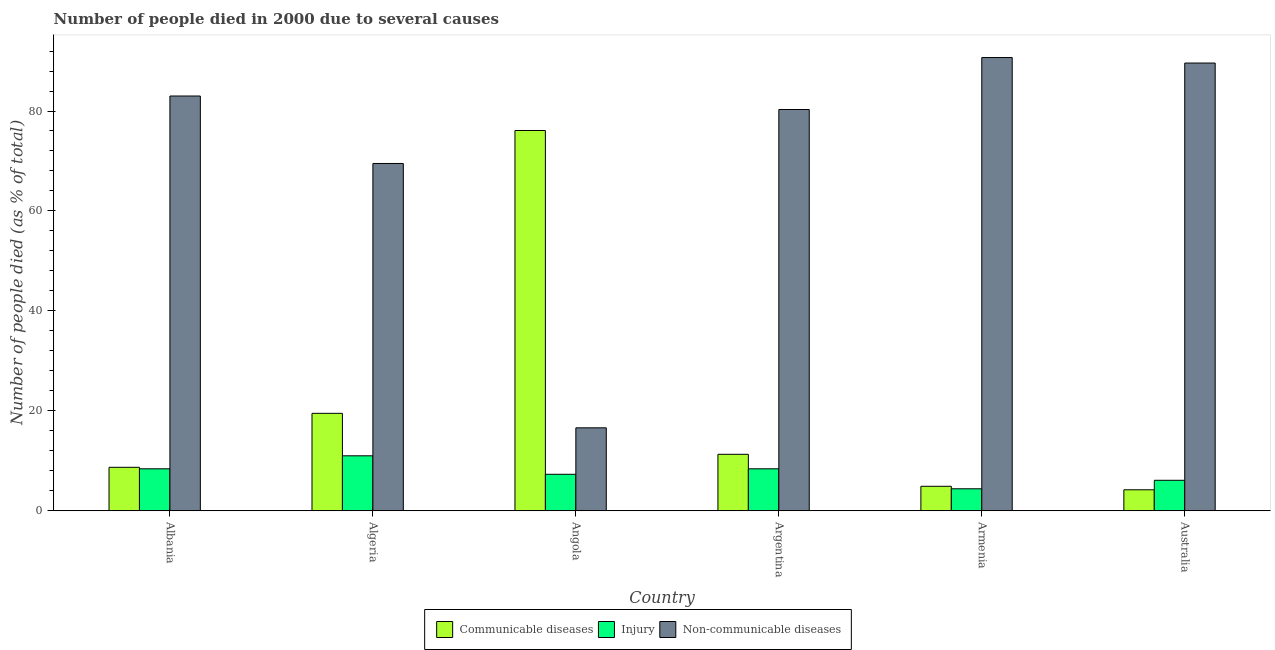How many different coloured bars are there?
Your response must be concise. 3. How many bars are there on the 6th tick from the left?
Ensure brevity in your answer.  3. What is the label of the 2nd group of bars from the left?
Your answer should be compact. Algeria. In how many cases, is the number of bars for a given country not equal to the number of legend labels?
Provide a succinct answer. 0. What is the number of people who died of injury in Argentina?
Provide a succinct answer. 8.4. In which country was the number of people who died of injury maximum?
Your answer should be very brief. Algeria. What is the total number of people who died of injury in the graph?
Make the answer very short. 45.6. What is the difference between the number of people who died of communicable diseases in Angola and the number of people who died of injury in Argentina?
Offer a very short reply. 67.7. What is the average number of people who dies of non-communicable diseases per country?
Offer a very short reply. 71.62. What is the difference between the number of people who dies of non-communicable diseases and number of people who died of communicable diseases in Armenia?
Make the answer very short. 85.8. What is the ratio of the number of people who dies of non-communicable diseases in Argentina to that in Armenia?
Your response must be concise. 0.89. What is the difference between the highest and the second highest number of people who dies of non-communicable diseases?
Give a very brief answer. 1.1. What is the difference between the highest and the lowest number of people who died of injury?
Ensure brevity in your answer.  6.6. Is the sum of the number of people who died of injury in Albania and Argentina greater than the maximum number of people who dies of non-communicable diseases across all countries?
Your answer should be very brief. No. What does the 1st bar from the left in Albania represents?
Your answer should be very brief. Communicable diseases. What does the 1st bar from the right in Angola represents?
Provide a succinct answer. Non-communicable diseases. Is it the case that in every country, the sum of the number of people who died of communicable diseases and number of people who died of injury is greater than the number of people who dies of non-communicable diseases?
Your response must be concise. No. How many bars are there?
Ensure brevity in your answer.  18. Are all the bars in the graph horizontal?
Keep it short and to the point. No. Are the values on the major ticks of Y-axis written in scientific E-notation?
Make the answer very short. No. How many legend labels are there?
Offer a terse response. 3. How are the legend labels stacked?
Ensure brevity in your answer.  Horizontal. What is the title of the graph?
Keep it short and to the point. Number of people died in 2000 due to several causes. What is the label or title of the X-axis?
Offer a terse response. Country. What is the label or title of the Y-axis?
Provide a succinct answer. Number of people died (as % of total). What is the Number of people died (as % of total) in Communicable diseases in Albania?
Your answer should be very brief. 8.7. What is the Number of people died (as % of total) of Injury in Albania?
Your answer should be very brief. 8.4. What is the Number of people died (as % of total) in Non-communicable diseases in Albania?
Provide a succinct answer. 83. What is the Number of people died (as % of total) in Communicable diseases in Algeria?
Your response must be concise. 19.5. What is the Number of people died (as % of total) of Non-communicable diseases in Algeria?
Offer a very short reply. 69.5. What is the Number of people died (as % of total) in Communicable diseases in Angola?
Your response must be concise. 76.1. What is the Number of people died (as % of total) in Non-communicable diseases in Angola?
Keep it short and to the point. 16.6. What is the Number of people died (as % of total) of Communicable diseases in Argentina?
Provide a succinct answer. 11.3. What is the Number of people died (as % of total) of Non-communicable diseases in Argentina?
Your answer should be very brief. 80.3. What is the Number of people died (as % of total) of Communicable diseases in Armenia?
Your answer should be very brief. 4.9. What is the Number of people died (as % of total) of Injury in Armenia?
Your answer should be compact. 4.4. What is the Number of people died (as % of total) of Non-communicable diseases in Armenia?
Give a very brief answer. 90.7. What is the Number of people died (as % of total) in Communicable diseases in Australia?
Ensure brevity in your answer.  4.2. What is the Number of people died (as % of total) in Injury in Australia?
Your answer should be compact. 6.1. What is the Number of people died (as % of total) in Non-communicable diseases in Australia?
Provide a short and direct response. 89.6. Across all countries, what is the maximum Number of people died (as % of total) of Communicable diseases?
Provide a succinct answer. 76.1. Across all countries, what is the maximum Number of people died (as % of total) in Injury?
Offer a very short reply. 11. Across all countries, what is the maximum Number of people died (as % of total) in Non-communicable diseases?
Offer a terse response. 90.7. Across all countries, what is the minimum Number of people died (as % of total) in Injury?
Offer a terse response. 4.4. What is the total Number of people died (as % of total) in Communicable diseases in the graph?
Make the answer very short. 124.7. What is the total Number of people died (as % of total) of Injury in the graph?
Your response must be concise. 45.6. What is the total Number of people died (as % of total) of Non-communicable diseases in the graph?
Make the answer very short. 429.7. What is the difference between the Number of people died (as % of total) in Communicable diseases in Albania and that in Algeria?
Make the answer very short. -10.8. What is the difference between the Number of people died (as % of total) in Injury in Albania and that in Algeria?
Provide a succinct answer. -2.6. What is the difference between the Number of people died (as % of total) in Communicable diseases in Albania and that in Angola?
Provide a short and direct response. -67.4. What is the difference between the Number of people died (as % of total) in Injury in Albania and that in Angola?
Give a very brief answer. 1.1. What is the difference between the Number of people died (as % of total) in Non-communicable diseases in Albania and that in Angola?
Keep it short and to the point. 66.4. What is the difference between the Number of people died (as % of total) in Injury in Albania and that in Argentina?
Keep it short and to the point. 0. What is the difference between the Number of people died (as % of total) of Communicable diseases in Albania and that in Armenia?
Offer a terse response. 3.8. What is the difference between the Number of people died (as % of total) of Non-communicable diseases in Albania and that in Armenia?
Offer a very short reply. -7.7. What is the difference between the Number of people died (as % of total) of Communicable diseases in Albania and that in Australia?
Your answer should be compact. 4.5. What is the difference between the Number of people died (as % of total) in Injury in Albania and that in Australia?
Your response must be concise. 2.3. What is the difference between the Number of people died (as % of total) in Non-communicable diseases in Albania and that in Australia?
Offer a terse response. -6.6. What is the difference between the Number of people died (as % of total) in Communicable diseases in Algeria and that in Angola?
Keep it short and to the point. -56.6. What is the difference between the Number of people died (as % of total) in Non-communicable diseases in Algeria and that in Angola?
Give a very brief answer. 52.9. What is the difference between the Number of people died (as % of total) of Communicable diseases in Algeria and that in Argentina?
Your response must be concise. 8.2. What is the difference between the Number of people died (as % of total) of Communicable diseases in Algeria and that in Armenia?
Offer a terse response. 14.6. What is the difference between the Number of people died (as % of total) in Non-communicable diseases in Algeria and that in Armenia?
Provide a succinct answer. -21.2. What is the difference between the Number of people died (as % of total) in Non-communicable diseases in Algeria and that in Australia?
Your response must be concise. -20.1. What is the difference between the Number of people died (as % of total) of Communicable diseases in Angola and that in Argentina?
Provide a short and direct response. 64.8. What is the difference between the Number of people died (as % of total) in Injury in Angola and that in Argentina?
Give a very brief answer. -1.1. What is the difference between the Number of people died (as % of total) of Non-communicable diseases in Angola and that in Argentina?
Provide a short and direct response. -63.7. What is the difference between the Number of people died (as % of total) in Communicable diseases in Angola and that in Armenia?
Your response must be concise. 71.2. What is the difference between the Number of people died (as % of total) of Non-communicable diseases in Angola and that in Armenia?
Your answer should be very brief. -74.1. What is the difference between the Number of people died (as % of total) of Communicable diseases in Angola and that in Australia?
Your response must be concise. 71.9. What is the difference between the Number of people died (as % of total) of Injury in Angola and that in Australia?
Keep it short and to the point. 1.2. What is the difference between the Number of people died (as % of total) of Non-communicable diseases in Angola and that in Australia?
Keep it short and to the point. -73. What is the difference between the Number of people died (as % of total) of Communicable diseases in Argentina and that in Armenia?
Provide a succinct answer. 6.4. What is the difference between the Number of people died (as % of total) of Non-communicable diseases in Argentina and that in Armenia?
Keep it short and to the point. -10.4. What is the difference between the Number of people died (as % of total) in Communicable diseases in Argentina and that in Australia?
Your answer should be compact. 7.1. What is the difference between the Number of people died (as % of total) of Non-communicable diseases in Argentina and that in Australia?
Offer a terse response. -9.3. What is the difference between the Number of people died (as % of total) of Injury in Armenia and that in Australia?
Your response must be concise. -1.7. What is the difference between the Number of people died (as % of total) in Non-communicable diseases in Armenia and that in Australia?
Your response must be concise. 1.1. What is the difference between the Number of people died (as % of total) of Communicable diseases in Albania and the Number of people died (as % of total) of Non-communicable diseases in Algeria?
Keep it short and to the point. -60.8. What is the difference between the Number of people died (as % of total) in Injury in Albania and the Number of people died (as % of total) in Non-communicable diseases in Algeria?
Offer a very short reply. -61.1. What is the difference between the Number of people died (as % of total) in Communicable diseases in Albania and the Number of people died (as % of total) in Injury in Angola?
Provide a succinct answer. 1.4. What is the difference between the Number of people died (as % of total) in Communicable diseases in Albania and the Number of people died (as % of total) in Non-communicable diseases in Argentina?
Ensure brevity in your answer.  -71.6. What is the difference between the Number of people died (as % of total) of Injury in Albania and the Number of people died (as % of total) of Non-communicable diseases in Argentina?
Your answer should be very brief. -71.9. What is the difference between the Number of people died (as % of total) of Communicable diseases in Albania and the Number of people died (as % of total) of Non-communicable diseases in Armenia?
Your response must be concise. -82. What is the difference between the Number of people died (as % of total) of Injury in Albania and the Number of people died (as % of total) of Non-communicable diseases in Armenia?
Give a very brief answer. -82.3. What is the difference between the Number of people died (as % of total) in Communicable diseases in Albania and the Number of people died (as % of total) in Injury in Australia?
Give a very brief answer. 2.6. What is the difference between the Number of people died (as % of total) in Communicable diseases in Albania and the Number of people died (as % of total) in Non-communicable diseases in Australia?
Keep it short and to the point. -80.9. What is the difference between the Number of people died (as % of total) of Injury in Albania and the Number of people died (as % of total) of Non-communicable diseases in Australia?
Offer a very short reply. -81.2. What is the difference between the Number of people died (as % of total) of Communicable diseases in Algeria and the Number of people died (as % of total) of Injury in Angola?
Your response must be concise. 12.2. What is the difference between the Number of people died (as % of total) in Communicable diseases in Algeria and the Number of people died (as % of total) in Non-communicable diseases in Argentina?
Provide a succinct answer. -60.8. What is the difference between the Number of people died (as % of total) in Injury in Algeria and the Number of people died (as % of total) in Non-communicable diseases in Argentina?
Your answer should be compact. -69.3. What is the difference between the Number of people died (as % of total) in Communicable diseases in Algeria and the Number of people died (as % of total) in Non-communicable diseases in Armenia?
Offer a terse response. -71.2. What is the difference between the Number of people died (as % of total) in Injury in Algeria and the Number of people died (as % of total) in Non-communicable diseases in Armenia?
Give a very brief answer. -79.7. What is the difference between the Number of people died (as % of total) of Communicable diseases in Algeria and the Number of people died (as % of total) of Injury in Australia?
Your response must be concise. 13.4. What is the difference between the Number of people died (as % of total) of Communicable diseases in Algeria and the Number of people died (as % of total) of Non-communicable diseases in Australia?
Offer a terse response. -70.1. What is the difference between the Number of people died (as % of total) in Injury in Algeria and the Number of people died (as % of total) in Non-communicable diseases in Australia?
Provide a succinct answer. -78.6. What is the difference between the Number of people died (as % of total) in Communicable diseases in Angola and the Number of people died (as % of total) in Injury in Argentina?
Provide a short and direct response. 67.7. What is the difference between the Number of people died (as % of total) of Injury in Angola and the Number of people died (as % of total) of Non-communicable diseases in Argentina?
Keep it short and to the point. -73. What is the difference between the Number of people died (as % of total) in Communicable diseases in Angola and the Number of people died (as % of total) in Injury in Armenia?
Keep it short and to the point. 71.7. What is the difference between the Number of people died (as % of total) in Communicable diseases in Angola and the Number of people died (as % of total) in Non-communicable diseases in Armenia?
Offer a terse response. -14.6. What is the difference between the Number of people died (as % of total) in Injury in Angola and the Number of people died (as % of total) in Non-communicable diseases in Armenia?
Ensure brevity in your answer.  -83.4. What is the difference between the Number of people died (as % of total) in Communicable diseases in Angola and the Number of people died (as % of total) in Injury in Australia?
Give a very brief answer. 70. What is the difference between the Number of people died (as % of total) of Communicable diseases in Angola and the Number of people died (as % of total) of Non-communicable diseases in Australia?
Your answer should be compact. -13.5. What is the difference between the Number of people died (as % of total) in Injury in Angola and the Number of people died (as % of total) in Non-communicable diseases in Australia?
Keep it short and to the point. -82.3. What is the difference between the Number of people died (as % of total) in Communicable diseases in Argentina and the Number of people died (as % of total) in Injury in Armenia?
Make the answer very short. 6.9. What is the difference between the Number of people died (as % of total) in Communicable diseases in Argentina and the Number of people died (as % of total) in Non-communicable diseases in Armenia?
Your answer should be compact. -79.4. What is the difference between the Number of people died (as % of total) in Injury in Argentina and the Number of people died (as % of total) in Non-communicable diseases in Armenia?
Ensure brevity in your answer.  -82.3. What is the difference between the Number of people died (as % of total) of Communicable diseases in Argentina and the Number of people died (as % of total) of Non-communicable diseases in Australia?
Offer a very short reply. -78.3. What is the difference between the Number of people died (as % of total) in Injury in Argentina and the Number of people died (as % of total) in Non-communicable diseases in Australia?
Your response must be concise. -81.2. What is the difference between the Number of people died (as % of total) in Communicable diseases in Armenia and the Number of people died (as % of total) in Non-communicable diseases in Australia?
Make the answer very short. -84.7. What is the difference between the Number of people died (as % of total) of Injury in Armenia and the Number of people died (as % of total) of Non-communicable diseases in Australia?
Ensure brevity in your answer.  -85.2. What is the average Number of people died (as % of total) of Communicable diseases per country?
Offer a very short reply. 20.78. What is the average Number of people died (as % of total) of Injury per country?
Your answer should be compact. 7.6. What is the average Number of people died (as % of total) of Non-communicable diseases per country?
Provide a succinct answer. 71.62. What is the difference between the Number of people died (as % of total) of Communicable diseases and Number of people died (as % of total) of Non-communicable diseases in Albania?
Offer a very short reply. -74.3. What is the difference between the Number of people died (as % of total) in Injury and Number of people died (as % of total) in Non-communicable diseases in Albania?
Offer a very short reply. -74.6. What is the difference between the Number of people died (as % of total) of Communicable diseases and Number of people died (as % of total) of Injury in Algeria?
Make the answer very short. 8.5. What is the difference between the Number of people died (as % of total) of Injury and Number of people died (as % of total) of Non-communicable diseases in Algeria?
Provide a short and direct response. -58.5. What is the difference between the Number of people died (as % of total) in Communicable diseases and Number of people died (as % of total) in Injury in Angola?
Offer a terse response. 68.8. What is the difference between the Number of people died (as % of total) of Communicable diseases and Number of people died (as % of total) of Non-communicable diseases in Angola?
Offer a very short reply. 59.5. What is the difference between the Number of people died (as % of total) of Injury and Number of people died (as % of total) of Non-communicable diseases in Angola?
Offer a very short reply. -9.3. What is the difference between the Number of people died (as % of total) in Communicable diseases and Number of people died (as % of total) in Injury in Argentina?
Your answer should be very brief. 2.9. What is the difference between the Number of people died (as % of total) of Communicable diseases and Number of people died (as % of total) of Non-communicable diseases in Argentina?
Give a very brief answer. -69. What is the difference between the Number of people died (as % of total) in Injury and Number of people died (as % of total) in Non-communicable diseases in Argentina?
Make the answer very short. -71.9. What is the difference between the Number of people died (as % of total) in Communicable diseases and Number of people died (as % of total) in Injury in Armenia?
Provide a short and direct response. 0.5. What is the difference between the Number of people died (as % of total) of Communicable diseases and Number of people died (as % of total) of Non-communicable diseases in Armenia?
Give a very brief answer. -85.8. What is the difference between the Number of people died (as % of total) of Injury and Number of people died (as % of total) of Non-communicable diseases in Armenia?
Ensure brevity in your answer.  -86.3. What is the difference between the Number of people died (as % of total) of Communicable diseases and Number of people died (as % of total) of Injury in Australia?
Ensure brevity in your answer.  -1.9. What is the difference between the Number of people died (as % of total) in Communicable diseases and Number of people died (as % of total) in Non-communicable diseases in Australia?
Your answer should be very brief. -85.4. What is the difference between the Number of people died (as % of total) in Injury and Number of people died (as % of total) in Non-communicable diseases in Australia?
Your response must be concise. -83.5. What is the ratio of the Number of people died (as % of total) in Communicable diseases in Albania to that in Algeria?
Your response must be concise. 0.45. What is the ratio of the Number of people died (as % of total) in Injury in Albania to that in Algeria?
Give a very brief answer. 0.76. What is the ratio of the Number of people died (as % of total) in Non-communicable diseases in Albania to that in Algeria?
Your answer should be compact. 1.19. What is the ratio of the Number of people died (as % of total) of Communicable diseases in Albania to that in Angola?
Ensure brevity in your answer.  0.11. What is the ratio of the Number of people died (as % of total) in Injury in Albania to that in Angola?
Ensure brevity in your answer.  1.15. What is the ratio of the Number of people died (as % of total) of Non-communicable diseases in Albania to that in Angola?
Make the answer very short. 5. What is the ratio of the Number of people died (as % of total) of Communicable diseases in Albania to that in Argentina?
Your answer should be very brief. 0.77. What is the ratio of the Number of people died (as % of total) of Non-communicable diseases in Albania to that in Argentina?
Offer a terse response. 1.03. What is the ratio of the Number of people died (as % of total) of Communicable diseases in Albania to that in Armenia?
Your response must be concise. 1.78. What is the ratio of the Number of people died (as % of total) in Injury in Albania to that in Armenia?
Offer a very short reply. 1.91. What is the ratio of the Number of people died (as % of total) of Non-communicable diseases in Albania to that in Armenia?
Your answer should be very brief. 0.92. What is the ratio of the Number of people died (as % of total) of Communicable diseases in Albania to that in Australia?
Provide a succinct answer. 2.07. What is the ratio of the Number of people died (as % of total) in Injury in Albania to that in Australia?
Your answer should be very brief. 1.38. What is the ratio of the Number of people died (as % of total) in Non-communicable diseases in Albania to that in Australia?
Give a very brief answer. 0.93. What is the ratio of the Number of people died (as % of total) of Communicable diseases in Algeria to that in Angola?
Your answer should be very brief. 0.26. What is the ratio of the Number of people died (as % of total) of Injury in Algeria to that in Angola?
Provide a short and direct response. 1.51. What is the ratio of the Number of people died (as % of total) in Non-communicable diseases in Algeria to that in Angola?
Keep it short and to the point. 4.19. What is the ratio of the Number of people died (as % of total) of Communicable diseases in Algeria to that in Argentina?
Ensure brevity in your answer.  1.73. What is the ratio of the Number of people died (as % of total) of Injury in Algeria to that in Argentina?
Offer a terse response. 1.31. What is the ratio of the Number of people died (as % of total) of Non-communicable diseases in Algeria to that in Argentina?
Make the answer very short. 0.87. What is the ratio of the Number of people died (as % of total) in Communicable diseases in Algeria to that in Armenia?
Ensure brevity in your answer.  3.98. What is the ratio of the Number of people died (as % of total) in Injury in Algeria to that in Armenia?
Provide a succinct answer. 2.5. What is the ratio of the Number of people died (as % of total) of Non-communicable diseases in Algeria to that in Armenia?
Ensure brevity in your answer.  0.77. What is the ratio of the Number of people died (as % of total) of Communicable diseases in Algeria to that in Australia?
Your response must be concise. 4.64. What is the ratio of the Number of people died (as % of total) of Injury in Algeria to that in Australia?
Offer a terse response. 1.8. What is the ratio of the Number of people died (as % of total) of Non-communicable diseases in Algeria to that in Australia?
Your answer should be compact. 0.78. What is the ratio of the Number of people died (as % of total) in Communicable diseases in Angola to that in Argentina?
Your answer should be compact. 6.73. What is the ratio of the Number of people died (as % of total) in Injury in Angola to that in Argentina?
Provide a succinct answer. 0.87. What is the ratio of the Number of people died (as % of total) of Non-communicable diseases in Angola to that in Argentina?
Give a very brief answer. 0.21. What is the ratio of the Number of people died (as % of total) of Communicable diseases in Angola to that in Armenia?
Your response must be concise. 15.53. What is the ratio of the Number of people died (as % of total) of Injury in Angola to that in Armenia?
Offer a terse response. 1.66. What is the ratio of the Number of people died (as % of total) of Non-communicable diseases in Angola to that in Armenia?
Give a very brief answer. 0.18. What is the ratio of the Number of people died (as % of total) in Communicable diseases in Angola to that in Australia?
Offer a very short reply. 18.12. What is the ratio of the Number of people died (as % of total) in Injury in Angola to that in Australia?
Ensure brevity in your answer.  1.2. What is the ratio of the Number of people died (as % of total) in Non-communicable diseases in Angola to that in Australia?
Provide a succinct answer. 0.19. What is the ratio of the Number of people died (as % of total) of Communicable diseases in Argentina to that in Armenia?
Offer a terse response. 2.31. What is the ratio of the Number of people died (as % of total) of Injury in Argentina to that in Armenia?
Ensure brevity in your answer.  1.91. What is the ratio of the Number of people died (as % of total) of Non-communicable diseases in Argentina to that in Armenia?
Make the answer very short. 0.89. What is the ratio of the Number of people died (as % of total) of Communicable diseases in Argentina to that in Australia?
Provide a short and direct response. 2.69. What is the ratio of the Number of people died (as % of total) of Injury in Argentina to that in Australia?
Your answer should be compact. 1.38. What is the ratio of the Number of people died (as % of total) of Non-communicable diseases in Argentina to that in Australia?
Your answer should be very brief. 0.9. What is the ratio of the Number of people died (as % of total) in Injury in Armenia to that in Australia?
Make the answer very short. 0.72. What is the ratio of the Number of people died (as % of total) of Non-communicable diseases in Armenia to that in Australia?
Offer a very short reply. 1.01. What is the difference between the highest and the second highest Number of people died (as % of total) in Communicable diseases?
Your answer should be very brief. 56.6. What is the difference between the highest and the second highest Number of people died (as % of total) of Injury?
Provide a succinct answer. 2.6. What is the difference between the highest and the second highest Number of people died (as % of total) of Non-communicable diseases?
Provide a succinct answer. 1.1. What is the difference between the highest and the lowest Number of people died (as % of total) of Communicable diseases?
Your answer should be compact. 71.9. What is the difference between the highest and the lowest Number of people died (as % of total) in Non-communicable diseases?
Offer a very short reply. 74.1. 